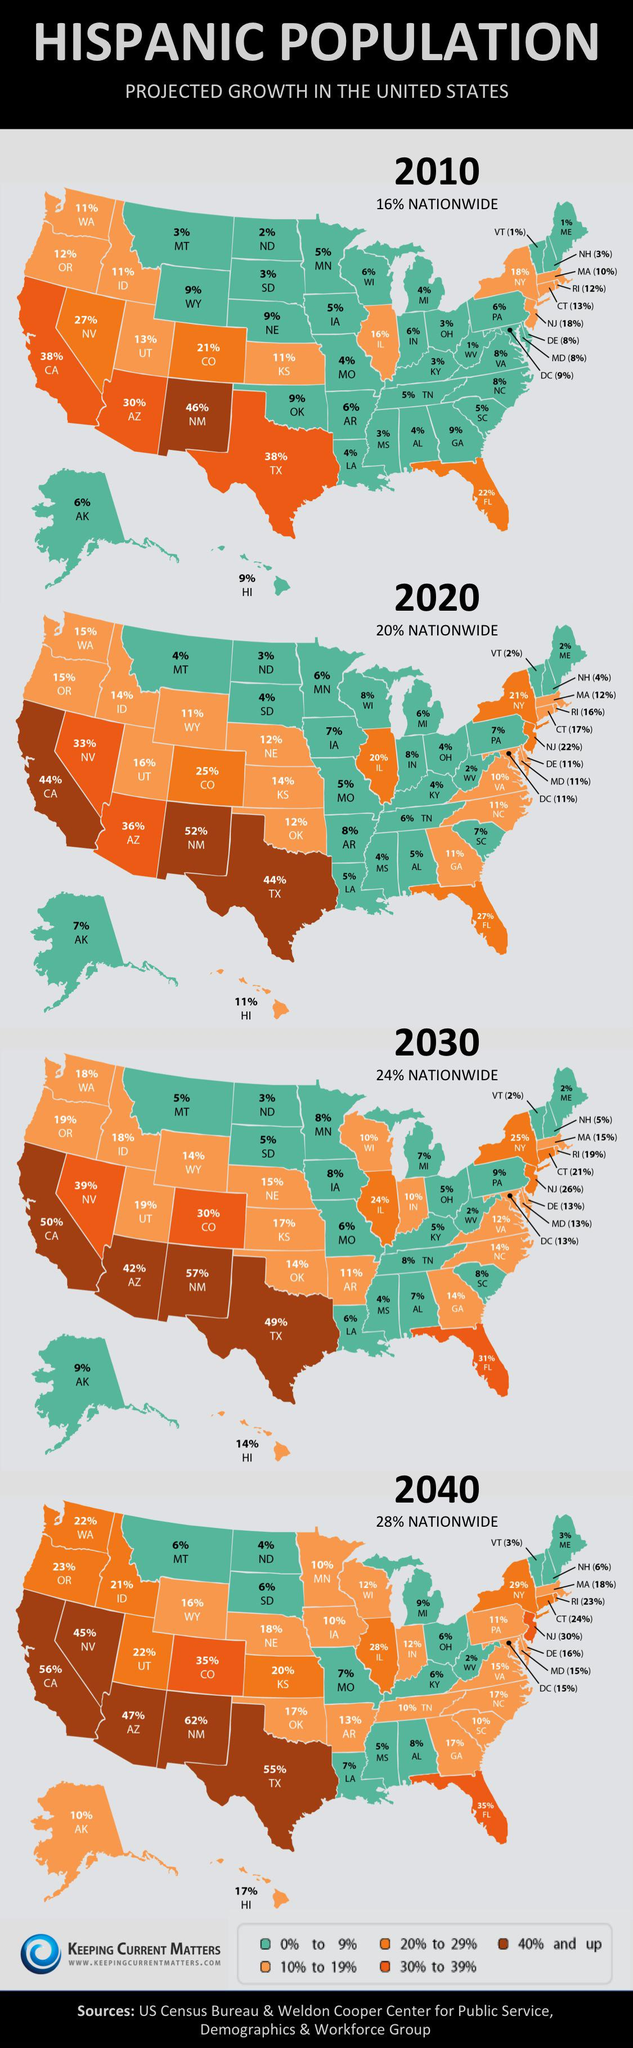Draw attention to some important aspects in this diagram. New Mexico is projected to have the highest growth percentage of the Hispanic population in the United States in 2020. The Hispanic population in Texas is projected to experience a growth rate of 49% in 2030. The Hispanic population in Alaska is projected to grow by 6% in 2010, according to estimates. The second-highest projected growth percentage of the Hispanic population in the United States is expected to occur in a state in the country. 